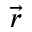<formula> <loc_0><loc_0><loc_500><loc_500>\vec { r }</formula> 